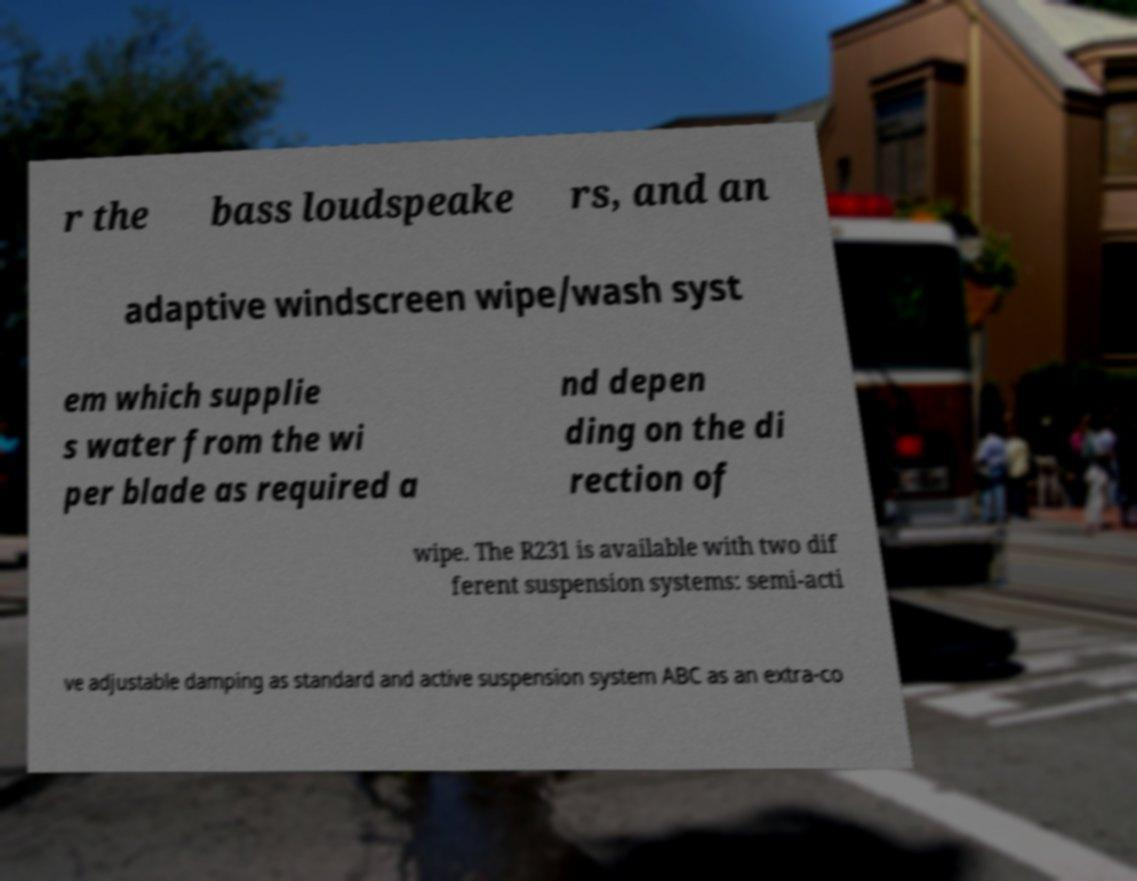Please read and relay the text visible in this image. What does it say? r the bass loudspeake rs, and an adaptive windscreen wipe/wash syst em which supplie s water from the wi per blade as required a nd depen ding on the di rection of wipe. The R231 is available with two dif ferent suspension systems: semi-acti ve adjustable damping as standard and active suspension system ABC as an extra-co 